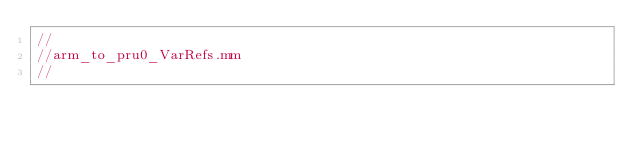<code> <loc_0><loc_0><loc_500><loc_500><_ObjectiveC_>//
//arm_to_pru0_VarRefs.mm
//</code> 